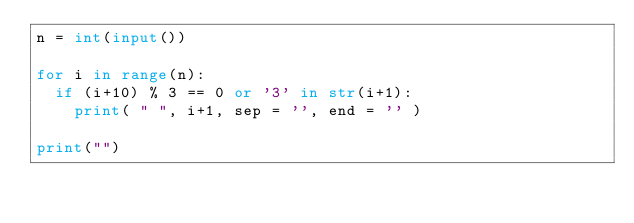<code> <loc_0><loc_0><loc_500><loc_500><_Python_>n = int(input())

for i in range(n):
  if (i+10) % 3 == 0 or '3' in str(i+1):
    print( " ", i+1, sep = '', end = '' )

print("")</code> 